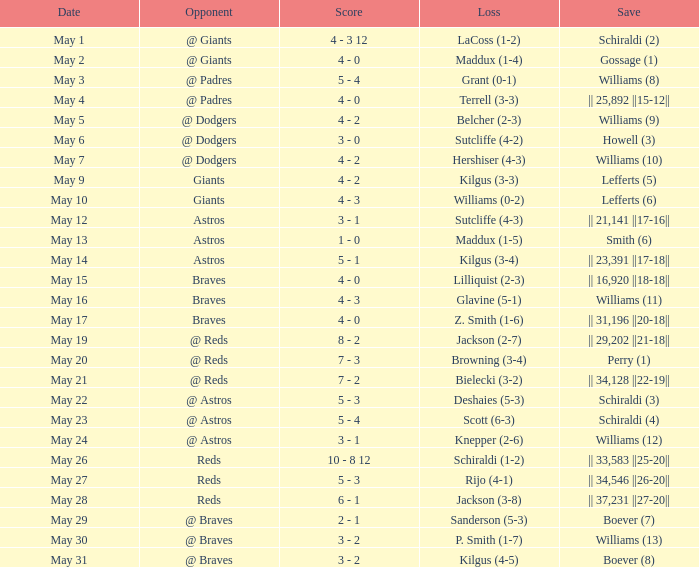Who secured the save for the braves game on the 15th of may? || 16,920 ||18-18||. 